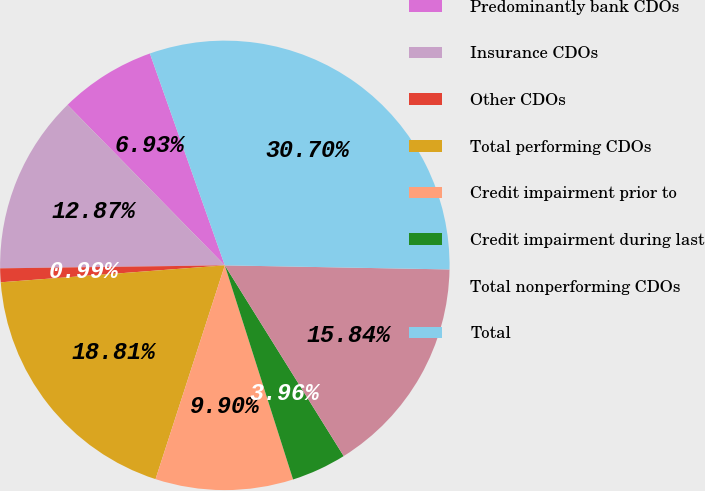Convert chart to OTSL. <chart><loc_0><loc_0><loc_500><loc_500><pie_chart><fcel>Predominantly bank CDOs<fcel>Insurance CDOs<fcel>Other CDOs<fcel>Total performing CDOs<fcel>Credit impairment prior to<fcel>Credit impairment during last<fcel>Total nonperforming CDOs<fcel>Total<nl><fcel>6.93%<fcel>12.87%<fcel>0.99%<fcel>18.81%<fcel>9.9%<fcel>3.96%<fcel>15.84%<fcel>30.7%<nl></chart> 